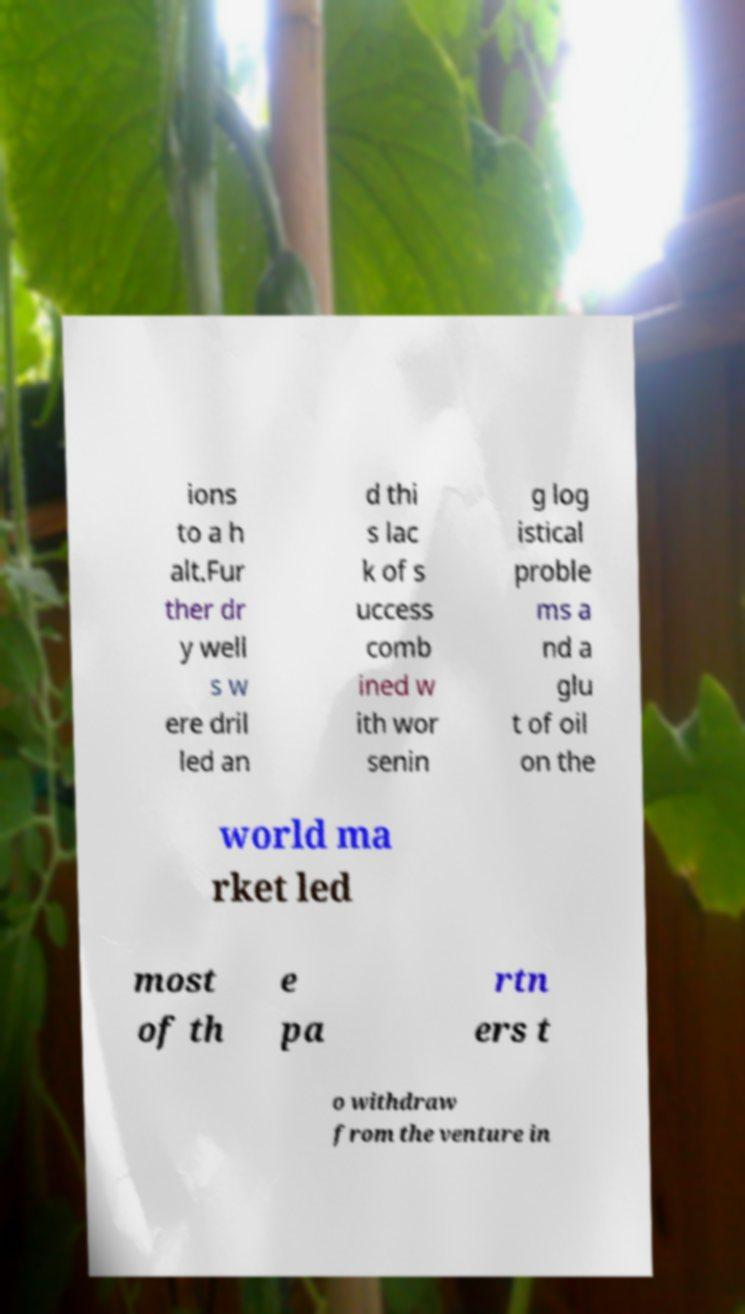There's text embedded in this image that I need extracted. Can you transcribe it verbatim? ions to a h alt.Fur ther dr y well s w ere dril led an d thi s lac k of s uccess comb ined w ith wor senin g log istical proble ms a nd a glu t of oil on the world ma rket led most of th e pa rtn ers t o withdraw from the venture in 